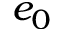<formula> <loc_0><loc_0><loc_500><loc_500>e _ { 0 }</formula> 